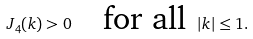<formula> <loc_0><loc_0><loc_500><loc_500>J _ { 4 } ( k ) > 0 \quad \text {for all } \left | { k } \right | \leq 1 .</formula> 